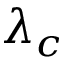<formula> <loc_0><loc_0><loc_500><loc_500>\lambda _ { c }</formula> 